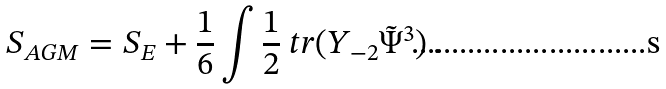Convert formula to latex. <formula><loc_0><loc_0><loc_500><loc_500>S _ { A G M } = S _ { E } + \frac { 1 } { 6 } \int \frac { 1 } { 2 } \ t r ( Y _ { - 2 } \tilde { \Psi } ^ { 3 } ) \, .</formula> 